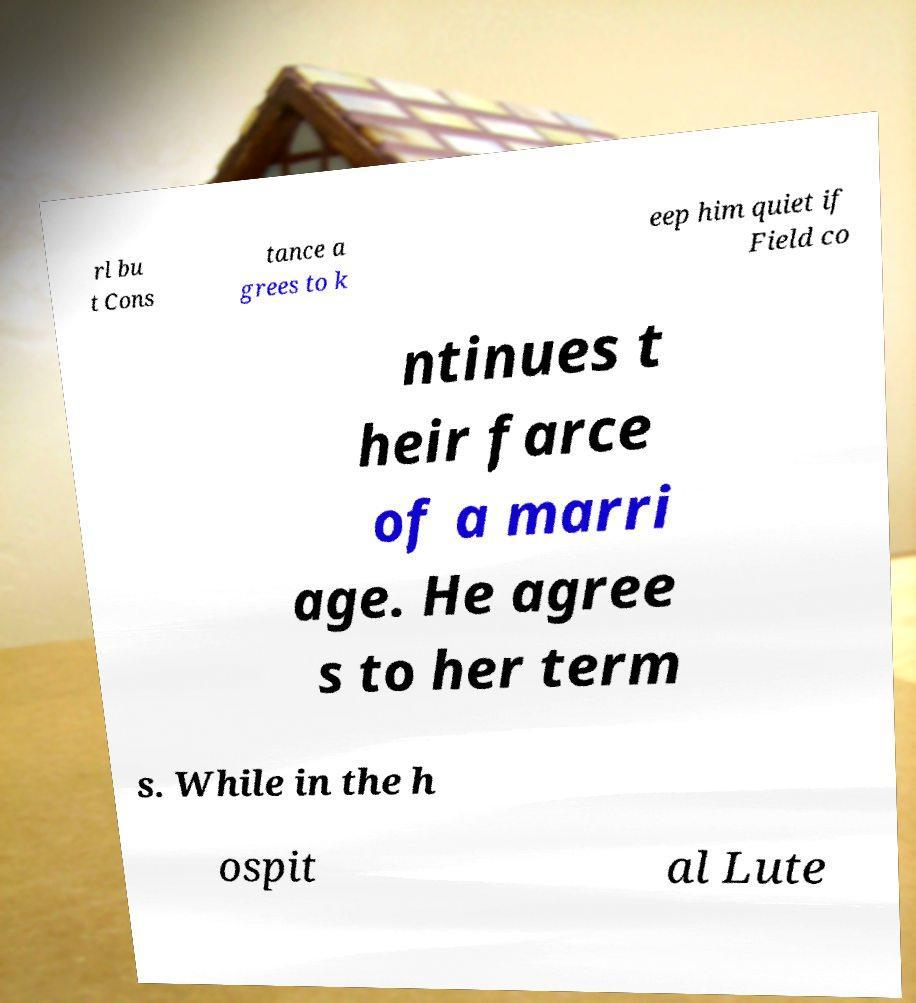For documentation purposes, I need the text within this image transcribed. Could you provide that? rl bu t Cons tance a grees to k eep him quiet if Field co ntinues t heir farce of a marri age. He agree s to her term s. While in the h ospit al Lute 